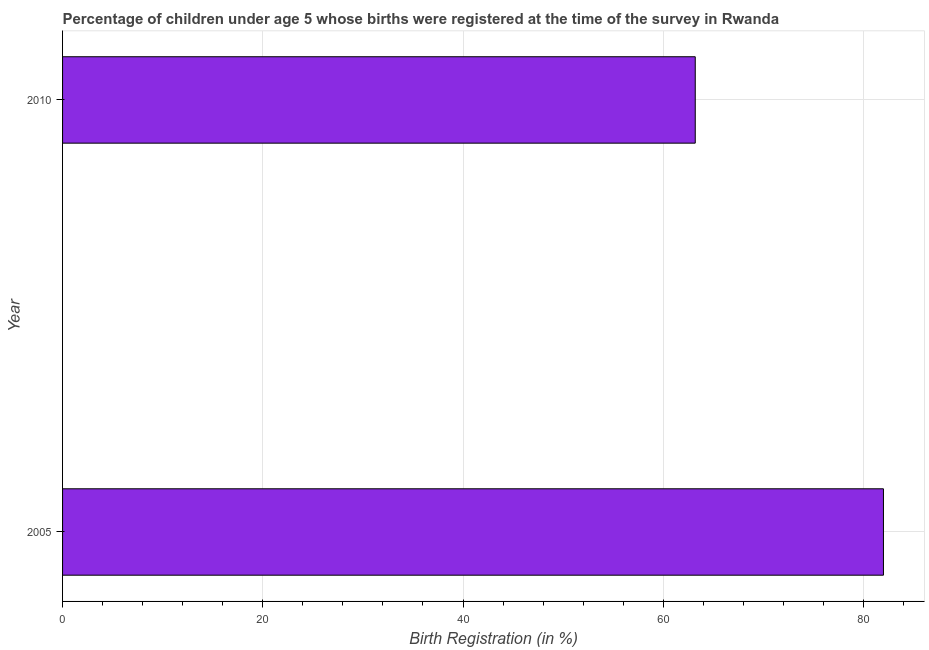Does the graph contain any zero values?
Provide a short and direct response. No. Does the graph contain grids?
Provide a succinct answer. Yes. What is the title of the graph?
Provide a succinct answer. Percentage of children under age 5 whose births were registered at the time of the survey in Rwanda. What is the label or title of the X-axis?
Offer a terse response. Birth Registration (in %). What is the birth registration in 2010?
Make the answer very short. 63.2. Across all years, what is the maximum birth registration?
Keep it short and to the point. 82. Across all years, what is the minimum birth registration?
Your response must be concise. 63.2. In which year was the birth registration maximum?
Provide a succinct answer. 2005. What is the sum of the birth registration?
Keep it short and to the point. 145.2. What is the difference between the birth registration in 2005 and 2010?
Your answer should be compact. 18.8. What is the average birth registration per year?
Make the answer very short. 72.6. What is the median birth registration?
Keep it short and to the point. 72.6. Do a majority of the years between 2010 and 2005 (inclusive) have birth registration greater than 36 %?
Make the answer very short. No. What is the ratio of the birth registration in 2005 to that in 2010?
Your answer should be very brief. 1.3. Is the birth registration in 2005 less than that in 2010?
Make the answer very short. No. In how many years, is the birth registration greater than the average birth registration taken over all years?
Ensure brevity in your answer.  1. How many bars are there?
Your answer should be compact. 2. How many years are there in the graph?
Your answer should be very brief. 2. Are the values on the major ticks of X-axis written in scientific E-notation?
Make the answer very short. No. What is the Birth Registration (in %) of 2005?
Provide a succinct answer. 82. What is the Birth Registration (in %) in 2010?
Offer a very short reply. 63.2. What is the ratio of the Birth Registration (in %) in 2005 to that in 2010?
Provide a short and direct response. 1.3. 